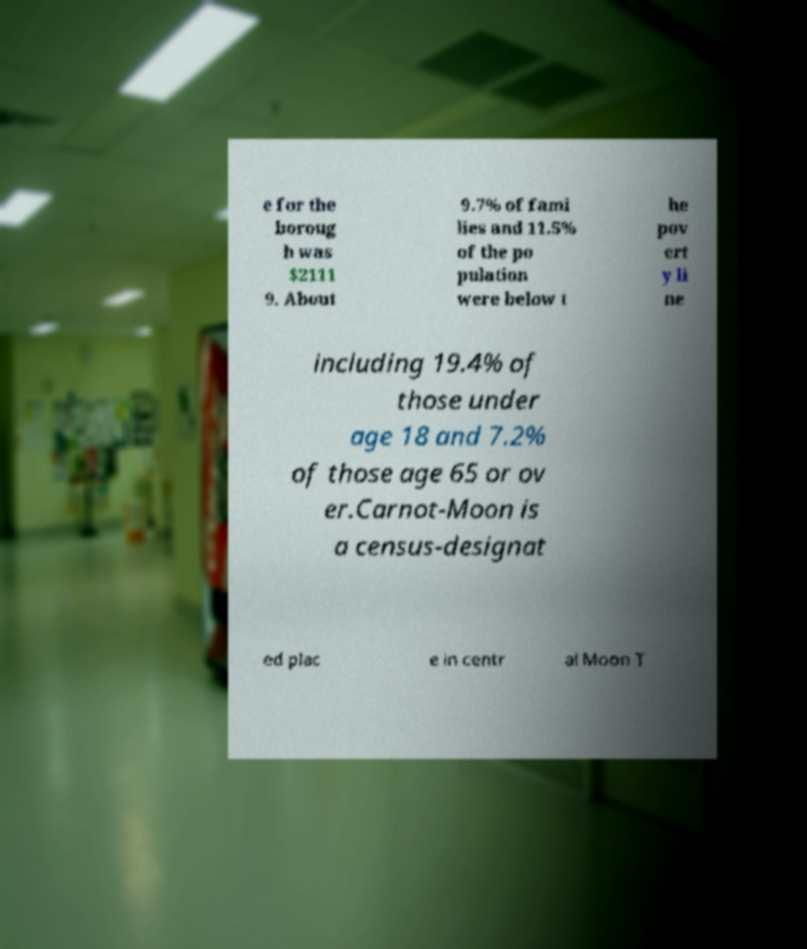There's text embedded in this image that I need extracted. Can you transcribe it verbatim? e for the boroug h was $2111 9. About 9.7% of fami lies and 11.5% of the po pulation were below t he pov ert y li ne including 19.4% of those under age 18 and 7.2% of those age 65 or ov er.Carnot-Moon is a census-designat ed plac e in centr al Moon T 